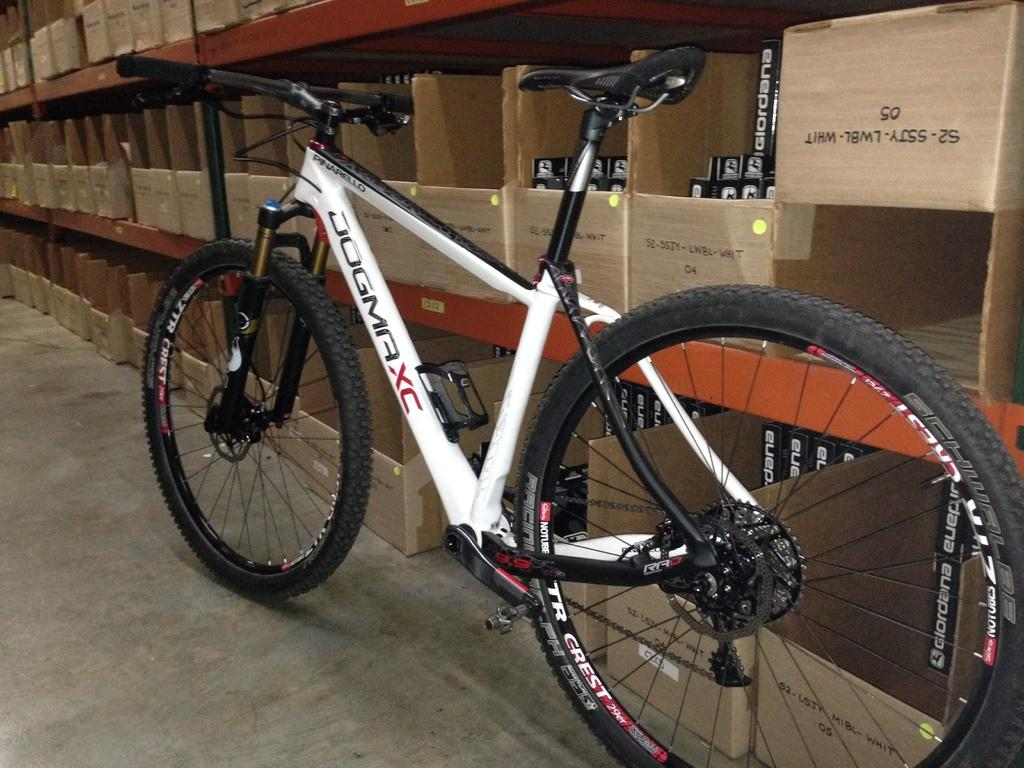What is the main object in the foreground of the image? There is a bicycle in the foreground of the image. How is the bicycle positioned in the image? The bicycle is on the floor. What can be seen in the background of the image? There are racks in the background of the image. What type of items are stored in the racks? Cartoon boxes are present in the racks. Where was the image taken? The image was taken in a showroom. What type of bone is visible in the image? There is no bone present in the image. What month is depicted in the image? The image does not depict a specific month; it shows a bicycle, racks, and cartoon boxes in a showroom. 